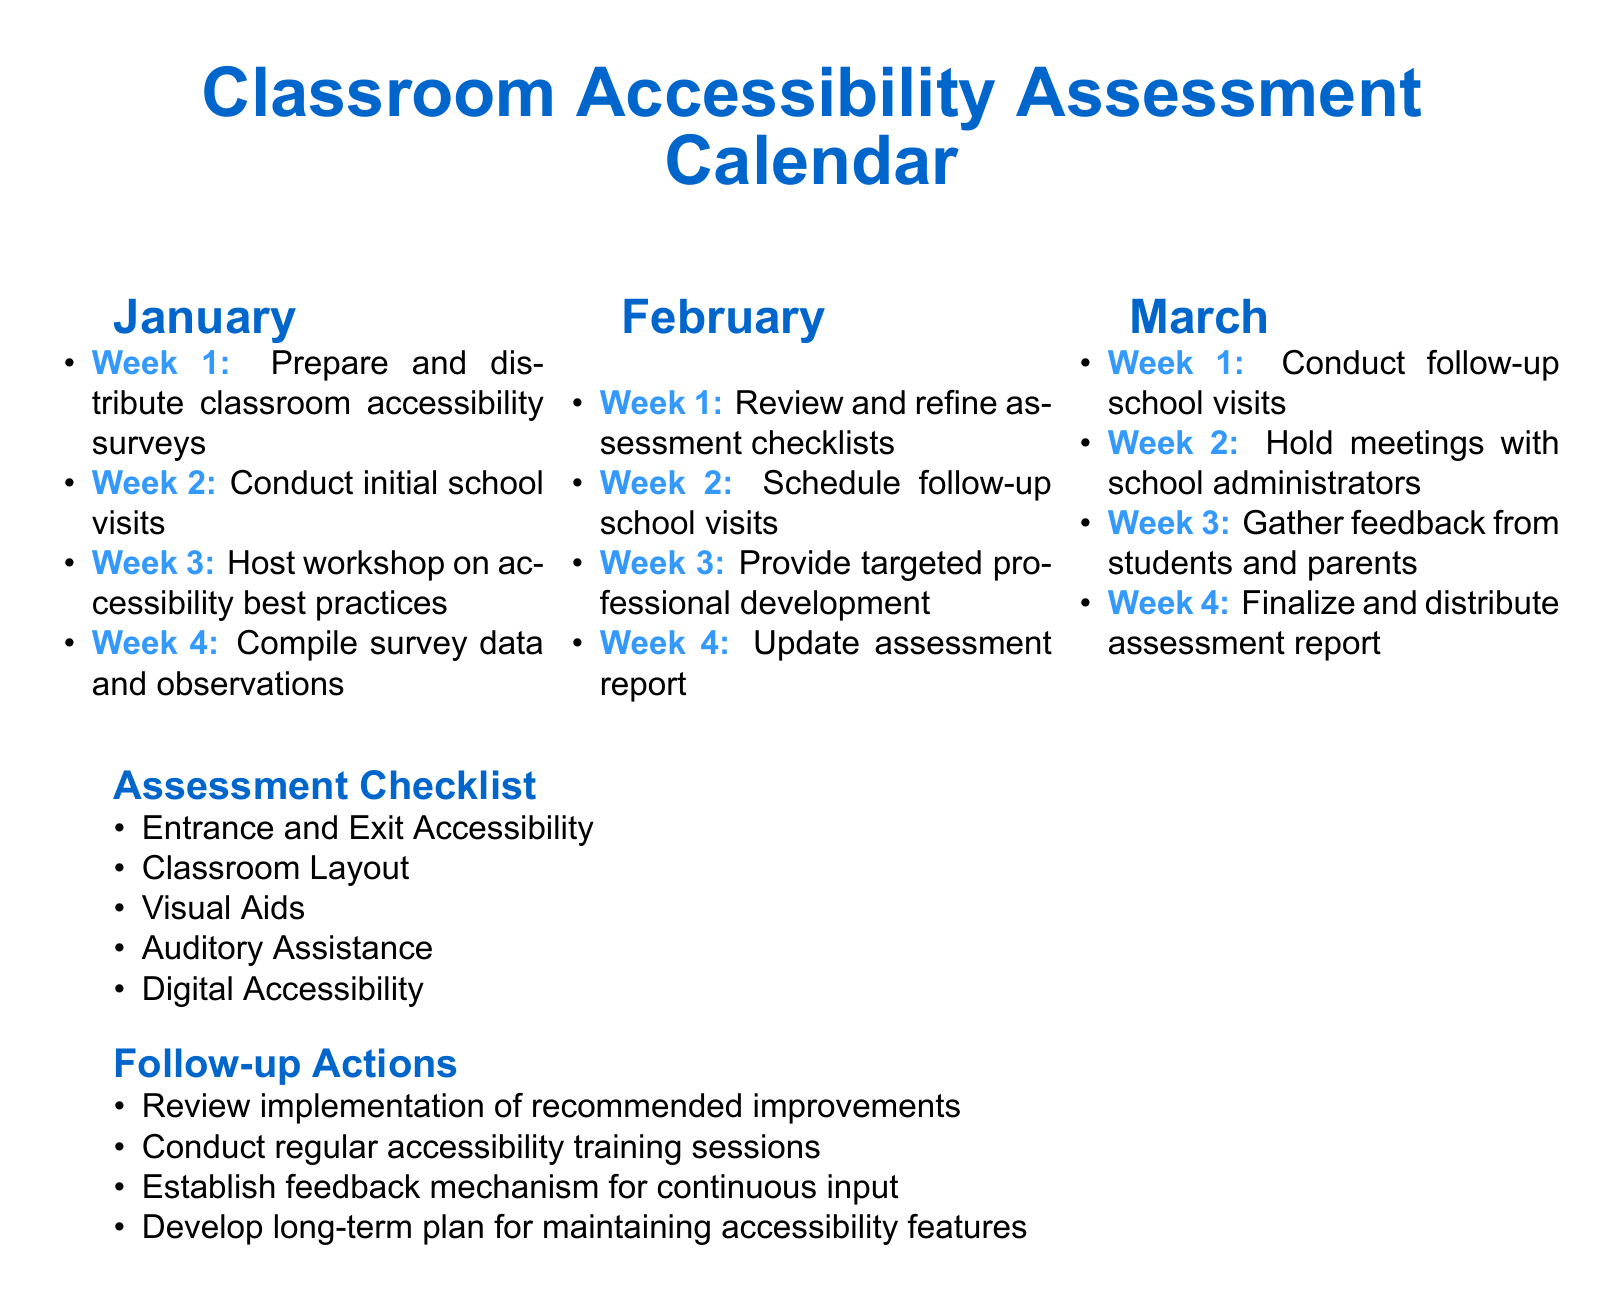What is the purpose of the first week in January? The first week in January is dedicated to preparing and distributing classroom accessibility surveys.
Answer: Prepare and distribute classroom accessibility surveys How many weeks are designated for follow-up school visits? Follow-up school visits are scheduled in February and March, indicating a total of two weeks.
Answer: 2 weeks What section includes the items related to visual and auditory assistance? The assessment checklist section includes items related to visual and auditory assistance.
Answer: Assessment Checklist What is the specific action taken in the third week of February? In the third week of February, targeted professional development is provided.
Answer: Provide targeted professional development What do the follow-up actions aim to establish for continuous input? The follow-up actions aim to establish a feedback mechanism for continuous input.
Answer: Feedback mechanism What month has the most activities scheduled in the calendar? January has four activities scheduled, which is the most in comparison to the other months.
Answer: January What is one of the items listed under entrance and exit accessibility? The checklist includes assessing the entrance and exit accessibility, which is a critical item under that category.
Answer: Entrance and Exit Accessibility How many weeks in total are allocated to host workshops and meetings? Workshops and meetings are scheduled over two weeks, one week for workshop and one for meetings.
Answer: 2 weeks What is due at the end of March according to the calendar? The calendar states that the assessment report is finalized and distributed at the end of March.
Answer: Finalize and distribute assessment report 